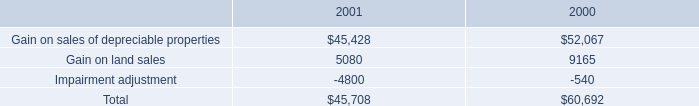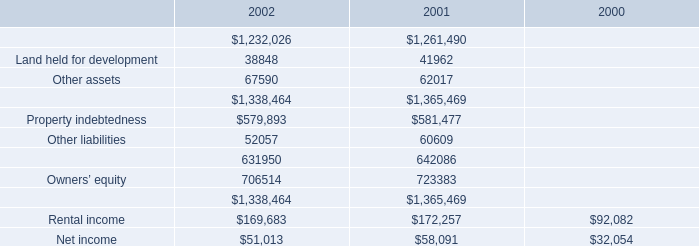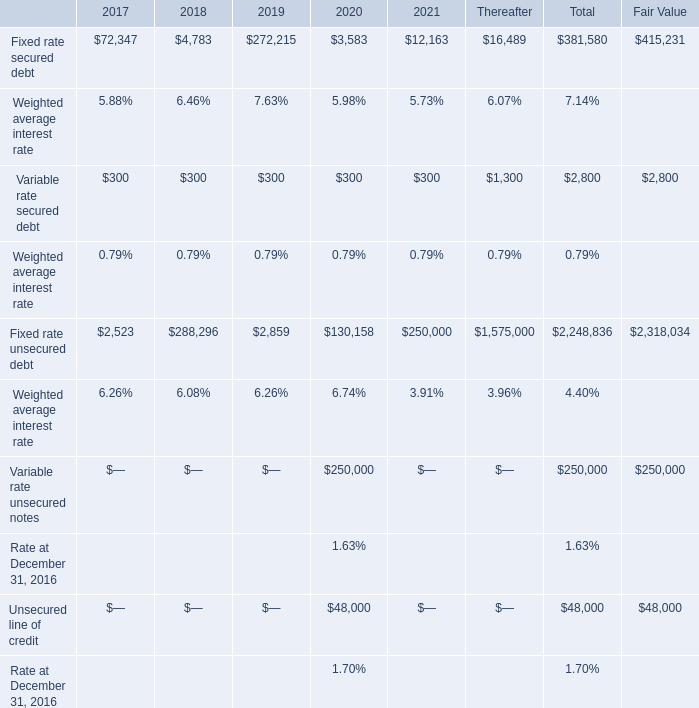What's the growth rate of Fixed rate secured debt in 2021? 
Computations: ((12163 - 3583) / 3583)
Answer: 2.39464. 